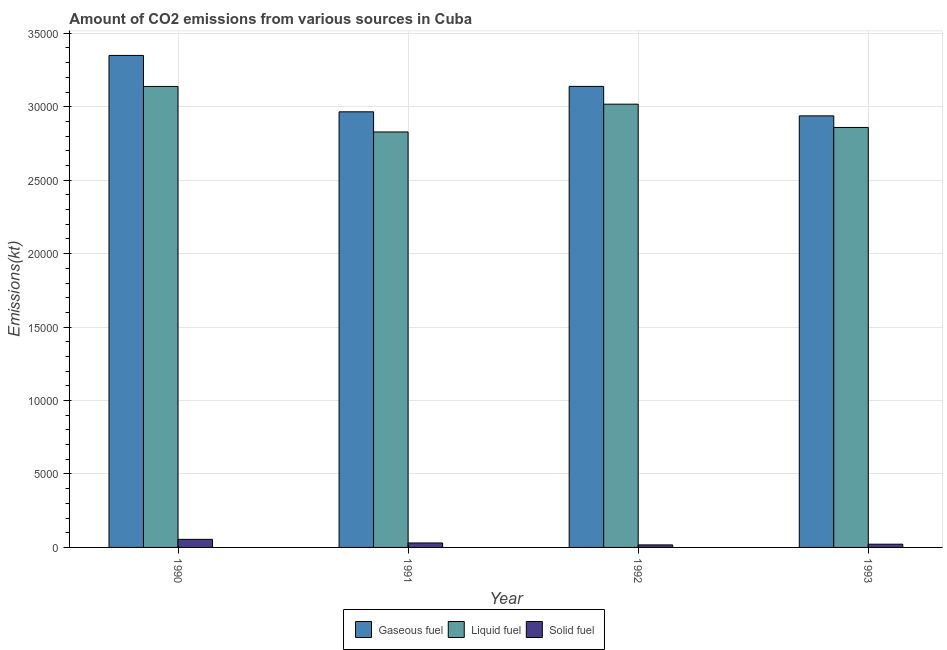How many different coloured bars are there?
Ensure brevity in your answer.  3. Are the number of bars per tick equal to the number of legend labels?
Your answer should be very brief. Yes. How many bars are there on the 1st tick from the left?
Ensure brevity in your answer.  3. What is the amount of co2 emissions from liquid fuel in 1990?
Offer a terse response. 3.14e+04. Across all years, what is the maximum amount of co2 emissions from liquid fuel?
Ensure brevity in your answer.  3.14e+04. Across all years, what is the minimum amount of co2 emissions from gaseous fuel?
Offer a very short reply. 2.94e+04. What is the total amount of co2 emissions from liquid fuel in the graph?
Ensure brevity in your answer.  1.18e+05. What is the difference between the amount of co2 emissions from gaseous fuel in 1990 and that in 1993?
Provide a short and direct response. 4114.37. What is the difference between the amount of co2 emissions from gaseous fuel in 1992 and the amount of co2 emissions from liquid fuel in 1990?
Your response must be concise. -2108.52. What is the average amount of co2 emissions from solid fuel per year?
Provide a short and direct response. 311.69. In the year 1992, what is the difference between the amount of co2 emissions from gaseous fuel and amount of co2 emissions from liquid fuel?
Provide a short and direct response. 0. What is the ratio of the amount of co2 emissions from gaseous fuel in 1990 to that in 1992?
Provide a succinct answer. 1.07. Is the difference between the amount of co2 emissions from gaseous fuel in 1990 and 1992 greater than the difference between the amount of co2 emissions from solid fuel in 1990 and 1992?
Keep it short and to the point. No. What is the difference between the highest and the second highest amount of co2 emissions from solid fuel?
Your answer should be compact. 245.69. What is the difference between the highest and the lowest amount of co2 emissions from liquid fuel?
Offer a terse response. 3098.62. In how many years, is the amount of co2 emissions from solid fuel greater than the average amount of co2 emissions from solid fuel taken over all years?
Make the answer very short. 1. What does the 2nd bar from the left in 1990 represents?
Give a very brief answer. Liquid fuel. What does the 2nd bar from the right in 1992 represents?
Give a very brief answer. Liquid fuel. Is it the case that in every year, the sum of the amount of co2 emissions from gaseous fuel and amount of co2 emissions from liquid fuel is greater than the amount of co2 emissions from solid fuel?
Keep it short and to the point. Yes. How many bars are there?
Make the answer very short. 12. Are all the bars in the graph horizontal?
Give a very brief answer. No. How many years are there in the graph?
Provide a succinct answer. 4. What is the difference between two consecutive major ticks on the Y-axis?
Your answer should be compact. 5000. Are the values on the major ticks of Y-axis written in scientific E-notation?
Keep it short and to the point. No. Does the graph contain grids?
Give a very brief answer. Yes. How many legend labels are there?
Offer a terse response. 3. What is the title of the graph?
Offer a terse response. Amount of CO2 emissions from various sources in Cuba. What is the label or title of the X-axis?
Your response must be concise. Year. What is the label or title of the Y-axis?
Your answer should be very brief. Emissions(kt). What is the Emissions(kt) in Gaseous fuel in 1990?
Offer a very short reply. 3.35e+04. What is the Emissions(kt) in Liquid fuel in 1990?
Provide a short and direct response. 3.14e+04. What is the Emissions(kt) of Solid fuel in 1990?
Your answer should be very brief. 550.05. What is the Emissions(kt) of Gaseous fuel in 1991?
Ensure brevity in your answer.  2.97e+04. What is the Emissions(kt) in Liquid fuel in 1991?
Your response must be concise. 2.83e+04. What is the Emissions(kt) in Solid fuel in 1991?
Your response must be concise. 304.36. What is the Emissions(kt) in Gaseous fuel in 1992?
Keep it short and to the point. 3.14e+04. What is the Emissions(kt) in Liquid fuel in 1992?
Your response must be concise. 3.02e+04. What is the Emissions(kt) of Solid fuel in 1992?
Keep it short and to the point. 172.35. What is the Emissions(kt) of Gaseous fuel in 1993?
Your response must be concise. 2.94e+04. What is the Emissions(kt) in Liquid fuel in 1993?
Give a very brief answer. 2.86e+04. What is the Emissions(kt) in Solid fuel in 1993?
Ensure brevity in your answer.  220.02. Across all years, what is the maximum Emissions(kt) in Gaseous fuel?
Your response must be concise. 3.35e+04. Across all years, what is the maximum Emissions(kt) in Liquid fuel?
Offer a very short reply. 3.14e+04. Across all years, what is the maximum Emissions(kt) in Solid fuel?
Ensure brevity in your answer.  550.05. Across all years, what is the minimum Emissions(kt) in Gaseous fuel?
Your response must be concise. 2.94e+04. Across all years, what is the minimum Emissions(kt) in Liquid fuel?
Ensure brevity in your answer.  2.83e+04. Across all years, what is the minimum Emissions(kt) of Solid fuel?
Your answer should be very brief. 172.35. What is the total Emissions(kt) of Gaseous fuel in the graph?
Keep it short and to the point. 1.24e+05. What is the total Emissions(kt) in Liquid fuel in the graph?
Your response must be concise. 1.18e+05. What is the total Emissions(kt) of Solid fuel in the graph?
Ensure brevity in your answer.  1246.78. What is the difference between the Emissions(kt) in Gaseous fuel in 1990 and that in 1991?
Your answer should be compact. 3839.35. What is the difference between the Emissions(kt) of Liquid fuel in 1990 and that in 1991?
Provide a succinct answer. 3098.61. What is the difference between the Emissions(kt) in Solid fuel in 1990 and that in 1991?
Your response must be concise. 245.69. What is the difference between the Emissions(kt) of Gaseous fuel in 1990 and that in 1992?
Give a very brief answer. 2108.53. What is the difference between the Emissions(kt) of Liquid fuel in 1990 and that in 1992?
Your response must be concise. 1206.44. What is the difference between the Emissions(kt) in Solid fuel in 1990 and that in 1992?
Offer a very short reply. 377.7. What is the difference between the Emissions(kt) of Gaseous fuel in 1990 and that in 1993?
Ensure brevity in your answer.  4114.37. What is the difference between the Emissions(kt) in Liquid fuel in 1990 and that in 1993?
Your answer should be very brief. 2790.59. What is the difference between the Emissions(kt) of Solid fuel in 1990 and that in 1993?
Provide a succinct answer. 330.03. What is the difference between the Emissions(kt) in Gaseous fuel in 1991 and that in 1992?
Make the answer very short. -1730.82. What is the difference between the Emissions(kt) in Liquid fuel in 1991 and that in 1992?
Your response must be concise. -1892.17. What is the difference between the Emissions(kt) in Solid fuel in 1991 and that in 1992?
Offer a very short reply. 132.01. What is the difference between the Emissions(kt) of Gaseous fuel in 1991 and that in 1993?
Ensure brevity in your answer.  275.02. What is the difference between the Emissions(kt) in Liquid fuel in 1991 and that in 1993?
Keep it short and to the point. -308.03. What is the difference between the Emissions(kt) of Solid fuel in 1991 and that in 1993?
Provide a short and direct response. 84.34. What is the difference between the Emissions(kt) of Gaseous fuel in 1992 and that in 1993?
Your answer should be very brief. 2005.85. What is the difference between the Emissions(kt) in Liquid fuel in 1992 and that in 1993?
Provide a succinct answer. 1584.14. What is the difference between the Emissions(kt) of Solid fuel in 1992 and that in 1993?
Provide a succinct answer. -47.67. What is the difference between the Emissions(kt) of Gaseous fuel in 1990 and the Emissions(kt) of Liquid fuel in 1991?
Give a very brief answer. 5210.81. What is the difference between the Emissions(kt) of Gaseous fuel in 1990 and the Emissions(kt) of Solid fuel in 1991?
Provide a short and direct response. 3.32e+04. What is the difference between the Emissions(kt) of Liquid fuel in 1990 and the Emissions(kt) of Solid fuel in 1991?
Make the answer very short. 3.11e+04. What is the difference between the Emissions(kt) in Gaseous fuel in 1990 and the Emissions(kt) in Liquid fuel in 1992?
Make the answer very short. 3318.64. What is the difference between the Emissions(kt) in Gaseous fuel in 1990 and the Emissions(kt) in Solid fuel in 1992?
Your response must be concise. 3.33e+04. What is the difference between the Emissions(kt) in Liquid fuel in 1990 and the Emissions(kt) in Solid fuel in 1992?
Your answer should be very brief. 3.12e+04. What is the difference between the Emissions(kt) of Gaseous fuel in 1990 and the Emissions(kt) of Liquid fuel in 1993?
Ensure brevity in your answer.  4902.78. What is the difference between the Emissions(kt) of Gaseous fuel in 1990 and the Emissions(kt) of Solid fuel in 1993?
Your answer should be very brief. 3.33e+04. What is the difference between the Emissions(kt) of Liquid fuel in 1990 and the Emissions(kt) of Solid fuel in 1993?
Your response must be concise. 3.12e+04. What is the difference between the Emissions(kt) in Gaseous fuel in 1991 and the Emissions(kt) in Liquid fuel in 1992?
Provide a short and direct response. -520.71. What is the difference between the Emissions(kt) of Gaseous fuel in 1991 and the Emissions(kt) of Solid fuel in 1992?
Your answer should be compact. 2.95e+04. What is the difference between the Emissions(kt) in Liquid fuel in 1991 and the Emissions(kt) in Solid fuel in 1992?
Offer a very short reply. 2.81e+04. What is the difference between the Emissions(kt) of Gaseous fuel in 1991 and the Emissions(kt) of Liquid fuel in 1993?
Your answer should be compact. 1063.43. What is the difference between the Emissions(kt) of Gaseous fuel in 1991 and the Emissions(kt) of Solid fuel in 1993?
Keep it short and to the point. 2.94e+04. What is the difference between the Emissions(kt) in Liquid fuel in 1991 and the Emissions(kt) in Solid fuel in 1993?
Ensure brevity in your answer.  2.81e+04. What is the difference between the Emissions(kt) in Gaseous fuel in 1992 and the Emissions(kt) in Liquid fuel in 1993?
Make the answer very short. 2794.25. What is the difference between the Emissions(kt) in Gaseous fuel in 1992 and the Emissions(kt) in Solid fuel in 1993?
Your answer should be very brief. 3.12e+04. What is the difference between the Emissions(kt) in Liquid fuel in 1992 and the Emissions(kt) in Solid fuel in 1993?
Offer a terse response. 3.00e+04. What is the average Emissions(kt) of Gaseous fuel per year?
Provide a short and direct response. 3.10e+04. What is the average Emissions(kt) of Liquid fuel per year?
Your response must be concise. 2.96e+04. What is the average Emissions(kt) of Solid fuel per year?
Your answer should be very brief. 311.69. In the year 1990, what is the difference between the Emissions(kt) of Gaseous fuel and Emissions(kt) of Liquid fuel?
Keep it short and to the point. 2112.19. In the year 1990, what is the difference between the Emissions(kt) in Gaseous fuel and Emissions(kt) in Solid fuel?
Ensure brevity in your answer.  3.29e+04. In the year 1990, what is the difference between the Emissions(kt) of Liquid fuel and Emissions(kt) of Solid fuel?
Provide a succinct answer. 3.08e+04. In the year 1991, what is the difference between the Emissions(kt) in Gaseous fuel and Emissions(kt) in Liquid fuel?
Keep it short and to the point. 1371.46. In the year 1991, what is the difference between the Emissions(kt) of Gaseous fuel and Emissions(kt) of Solid fuel?
Your answer should be very brief. 2.94e+04. In the year 1991, what is the difference between the Emissions(kt) in Liquid fuel and Emissions(kt) in Solid fuel?
Offer a very short reply. 2.80e+04. In the year 1992, what is the difference between the Emissions(kt) of Gaseous fuel and Emissions(kt) of Liquid fuel?
Provide a short and direct response. 1210.11. In the year 1992, what is the difference between the Emissions(kt) in Gaseous fuel and Emissions(kt) in Solid fuel?
Ensure brevity in your answer.  3.12e+04. In the year 1992, what is the difference between the Emissions(kt) of Liquid fuel and Emissions(kt) of Solid fuel?
Make the answer very short. 3.00e+04. In the year 1993, what is the difference between the Emissions(kt) in Gaseous fuel and Emissions(kt) in Liquid fuel?
Your answer should be compact. 788.4. In the year 1993, what is the difference between the Emissions(kt) of Gaseous fuel and Emissions(kt) of Solid fuel?
Make the answer very short. 2.92e+04. In the year 1993, what is the difference between the Emissions(kt) of Liquid fuel and Emissions(kt) of Solid fuel?
Your answer should be compact. 2.84e+04. What is the ratio of the Emissions(kt) in Gaseous fuel in 1990 to that in 1991?
Keep it short and to the point. 1.13. What is the ratio of the Emissions(kt) of Liquid fuel in 1990 to that in 1991?
Provide a succinct answer. 1.11. What is the ratio of the Emissions(kt) in Solid fuel in 1990 to that in 1991?
Your response must be concise. 1.81. What is the ratio of the Emissions(kt) in Gaseous fuel in 1990 to that in 1992?
Offer a very short reply. 1.07. What is the ratio of the Emissions(kt) in Liquid fuel in 1990 to that in 1992?
Provide a succinct answer. 1.04. What is the ratio of the Emissions(kt) in Solid fuel in 1990 to that in 1992?
Ensure brevity in your answer.  3.19. What is the ratio of the Emissions(kt) of Gaseous fuel in 1990 to that in 1993?
Offer a very short reply. 1.14. What is the ratio of the Emissions(kt) of Liquid fuel in 1990 to that in 1993?
Give a very brief answer. 1.1. What is the ratio of the Emissions(kt) in Solid fuel in 1990 to that in 1993?
Provide a succinct answer. 2.5. What is the ratio of the Emissions(kt) in Gaseous fuel in 1991 to that in 1992?
Keep it short and to the point. 0.94. What is the ratio of the Emissions(kt) in Liquid fuel in 1991 to that in 1992?
Ensure brevity in your answer.  0.94. What is the ratio of the Emissions(kt) in Solid fuel in 1991 to that in 1992?
Offer a very short reply. 1.77. What is the ratio of the Emissions(kt) of Gaseous fuel in 1991 to that in 1993?
Provide a short and direct response. 1.01. What is the ratio of the Emissions(kt) in Solid fuel in 1991 to that in 1993?
Your response must be concise. 1.38. What is the ratio of the Emissions(kt) in Gaseous fuel in 1992 to that in 1993?
Ensure brevity in your answer.  1.07. What is the ratio of the Emissions(kt) of Liquid fuel in 1992 to that in 1993?
Provide a short and direct response. 1.06. What is the ratio of the Emissions(kt) of Solid fuel in 1992 to that in 1993?
Keep it short and to the point. 0.78. What is the difference between the highest and the second highest Emissions(kt) in Gaseous fuel?
Make the answer very short. 2108.53. What is the difference between the highest and the second highest Emissions(kt) in Liquid fuel?
Your response must be concise. 1206.44. What is the difference between the highest and the second highest Emissions(kt) of Solid fuel?
Ensure brevity in your answer.  245.69. What is the difference between the highest and the lowest Emissions(kt) of Gaseous fuel?
Keep it short and to the point. 4114.37. What is the difference between the highest and the lowest Emissions(kt) in Liquid fuel?
Ensure brevity in your answer.  3098.61. What is the difference between the highest and the lowest Emissions(kt) of Solid fuel?
Offer a very short reply. 377.7. 